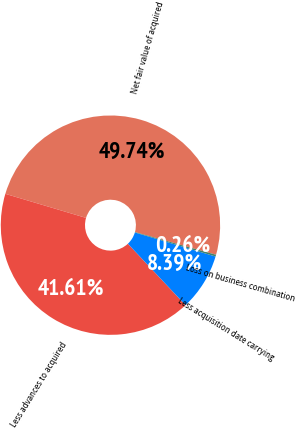<chart> <loc_0><loc_0><loc_500><loc_500><pie_chart><fcel>Net fair value of acquired<fcel>Less advances to acquired<fcel>Less acquisition date carrying<fcel>Loss on business combination<nl><fcel>49.74%<fcel>41.61%<fcel>8.39%<fcel>0.26%<nl></chart> 